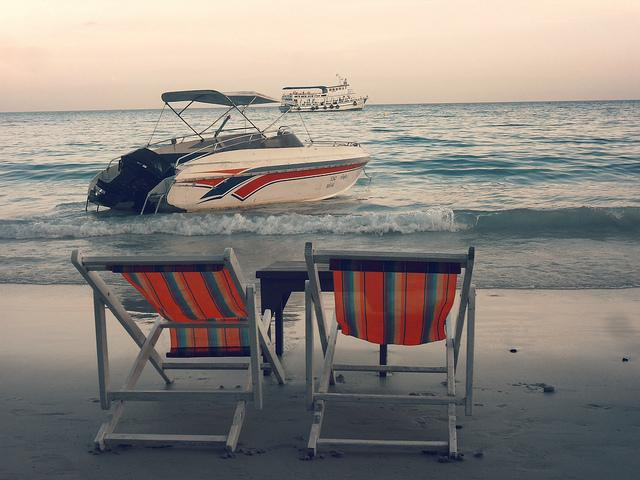What does the boat at the water's edge run on?

Choices:
A) engine
B) rowing
C) sails
D) no propulsion rowing 